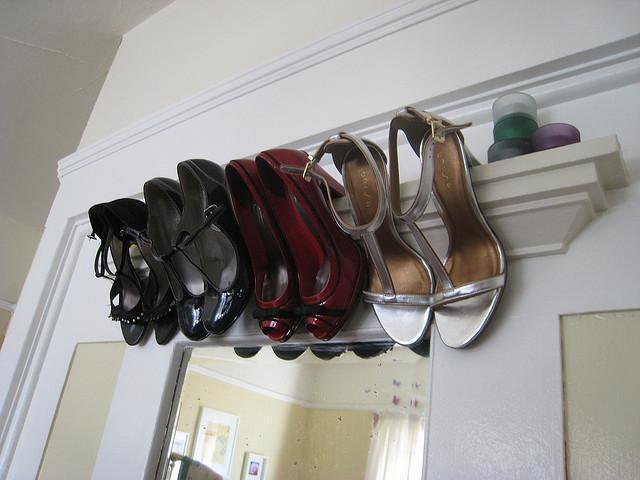How many shoes are facing down?
Give a very brief answer. 8. 